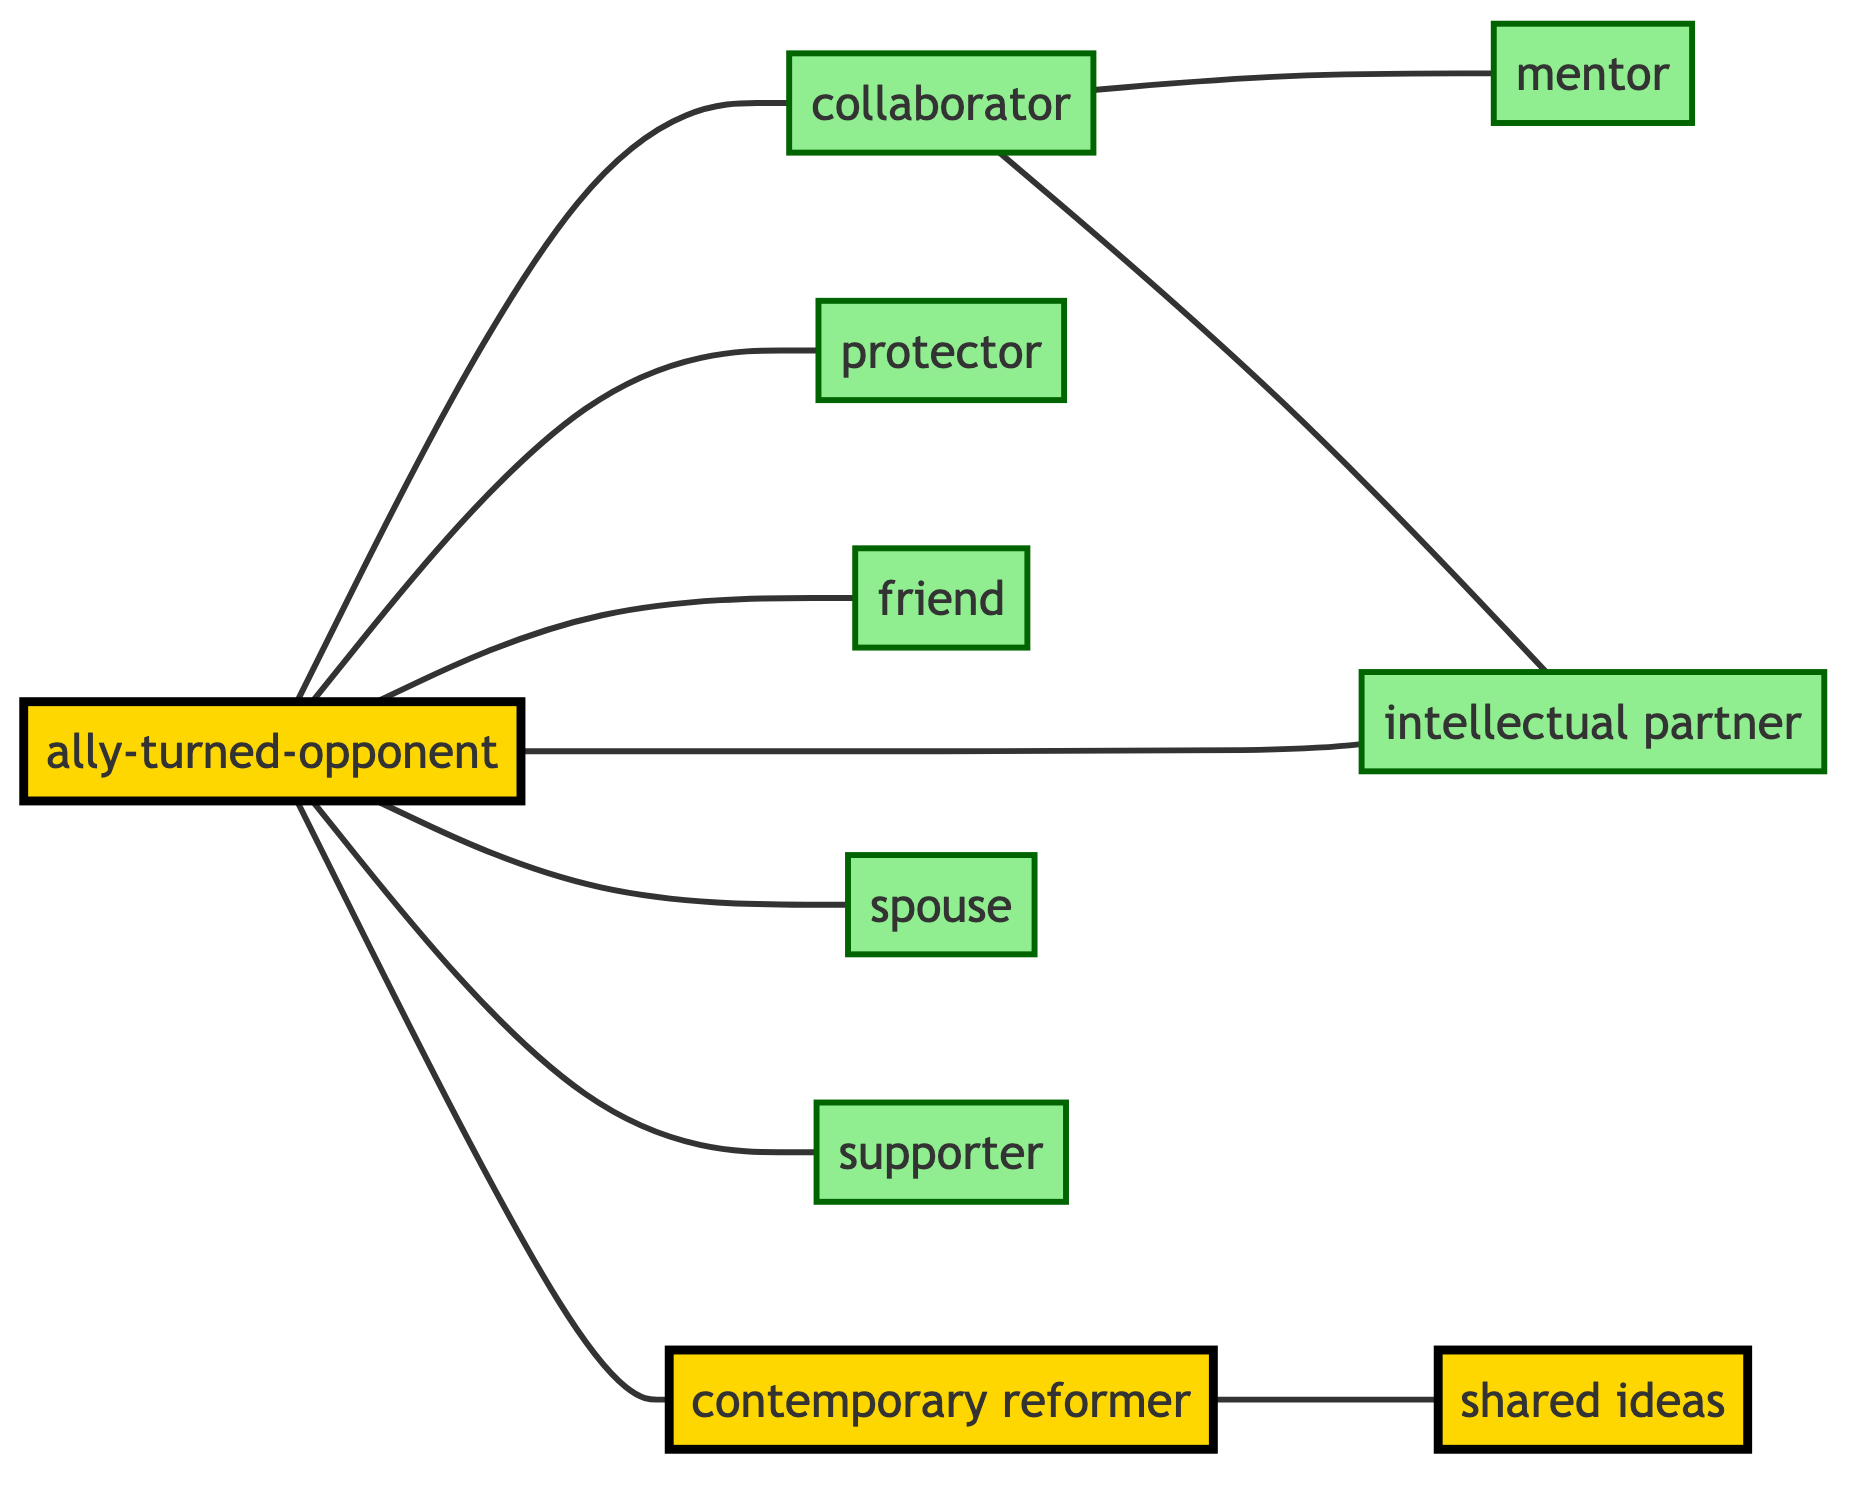What is the total number of key figures in the Reformation represented in the diagram? Count the number of nodes listed in the diagram. The nodes include: Martin Luther, Philip Melanchthon, Frederick the Wise, Johannes Bugenhagen, John Calvin, Huldrych Zwingli, Katherine von Bora, Johannes Reuchlin, Desiderius Erasmus, and Ulrich von Hutten, totaling 10.
Answer: 10 Who is labeled as Martin Luther's spouse? Look for the edge connecting Martin Luther to another node labeled with a relationship of "spouse." The connection is with Katherine von Bora, indicating she is his spouse.
Answer: Katherine von Bora Which figure is connected to Martin Luther as a "protector"? Identify the edge that starts from Martin Luther and check its labeled relationship. The edge to Frederick the Wise has the label "protector," which means he is connected to Martin Luther in this capacity.
Answer: Frederick the Wise List two figures who are labeled as "supporters" in the diagram. Review the nodes that have edges labeled as "supporter." Martin Luther is connected to Ulrich von Hutten in that way, which identifies Ulrich von Hutten as one supporter. There are no additional supporters, thus the answer is simply Ulrich von Hutten.
Answer: Ulrich von Hutten How many figures share a direct connection with Martin Luther? Check all the edges connected to the Martin Luther node. The connections are with Philip Melanchthon (collaborator), Frederick the Wise (protector), Johannes Bugenhagen (friend), John Calvin (contemporary reformer), Katherine von Bora (spouse), and Ulrich von Hutten (supporter), making a total of 6 connections.
Answer: 6 Which two figures are noted as "intellectual partners"? Review the edges that carry the label "intellectual partner." The connection appears between Philip Melanchthon and Desiderius Erasmus, indicating they share this relationship.
Answer: Philip Melanchthon and Desiderius Erasmus Who is the mentor of Philip Melanchthon according to the diagram? Look at the edges starting from Philip Melanchthon, specifically identifying the one labeled "mentor." This will lead you to Johannes Reuchlin, who is listed as his mentor.
Answer: Johannes Reuchlin What relationship links John Calvin to Huldrych Zwingli? Examine the edge that connects John Calvin and Huldrych Zwingli. The edge is labeled "shared ideas," establishing that their relationship is based on shared ideas.
Answer: shared ideas Which figure is indicated as an "ally-turned-opponent" of Martin Luther? Identify the edge connected to Martin Luther that is labeled "ally-turned-opponent." This points to Desiderius Erasmus, showing that he was once an ally but later became an opponent.
Answer: Desiderius Erasmus 